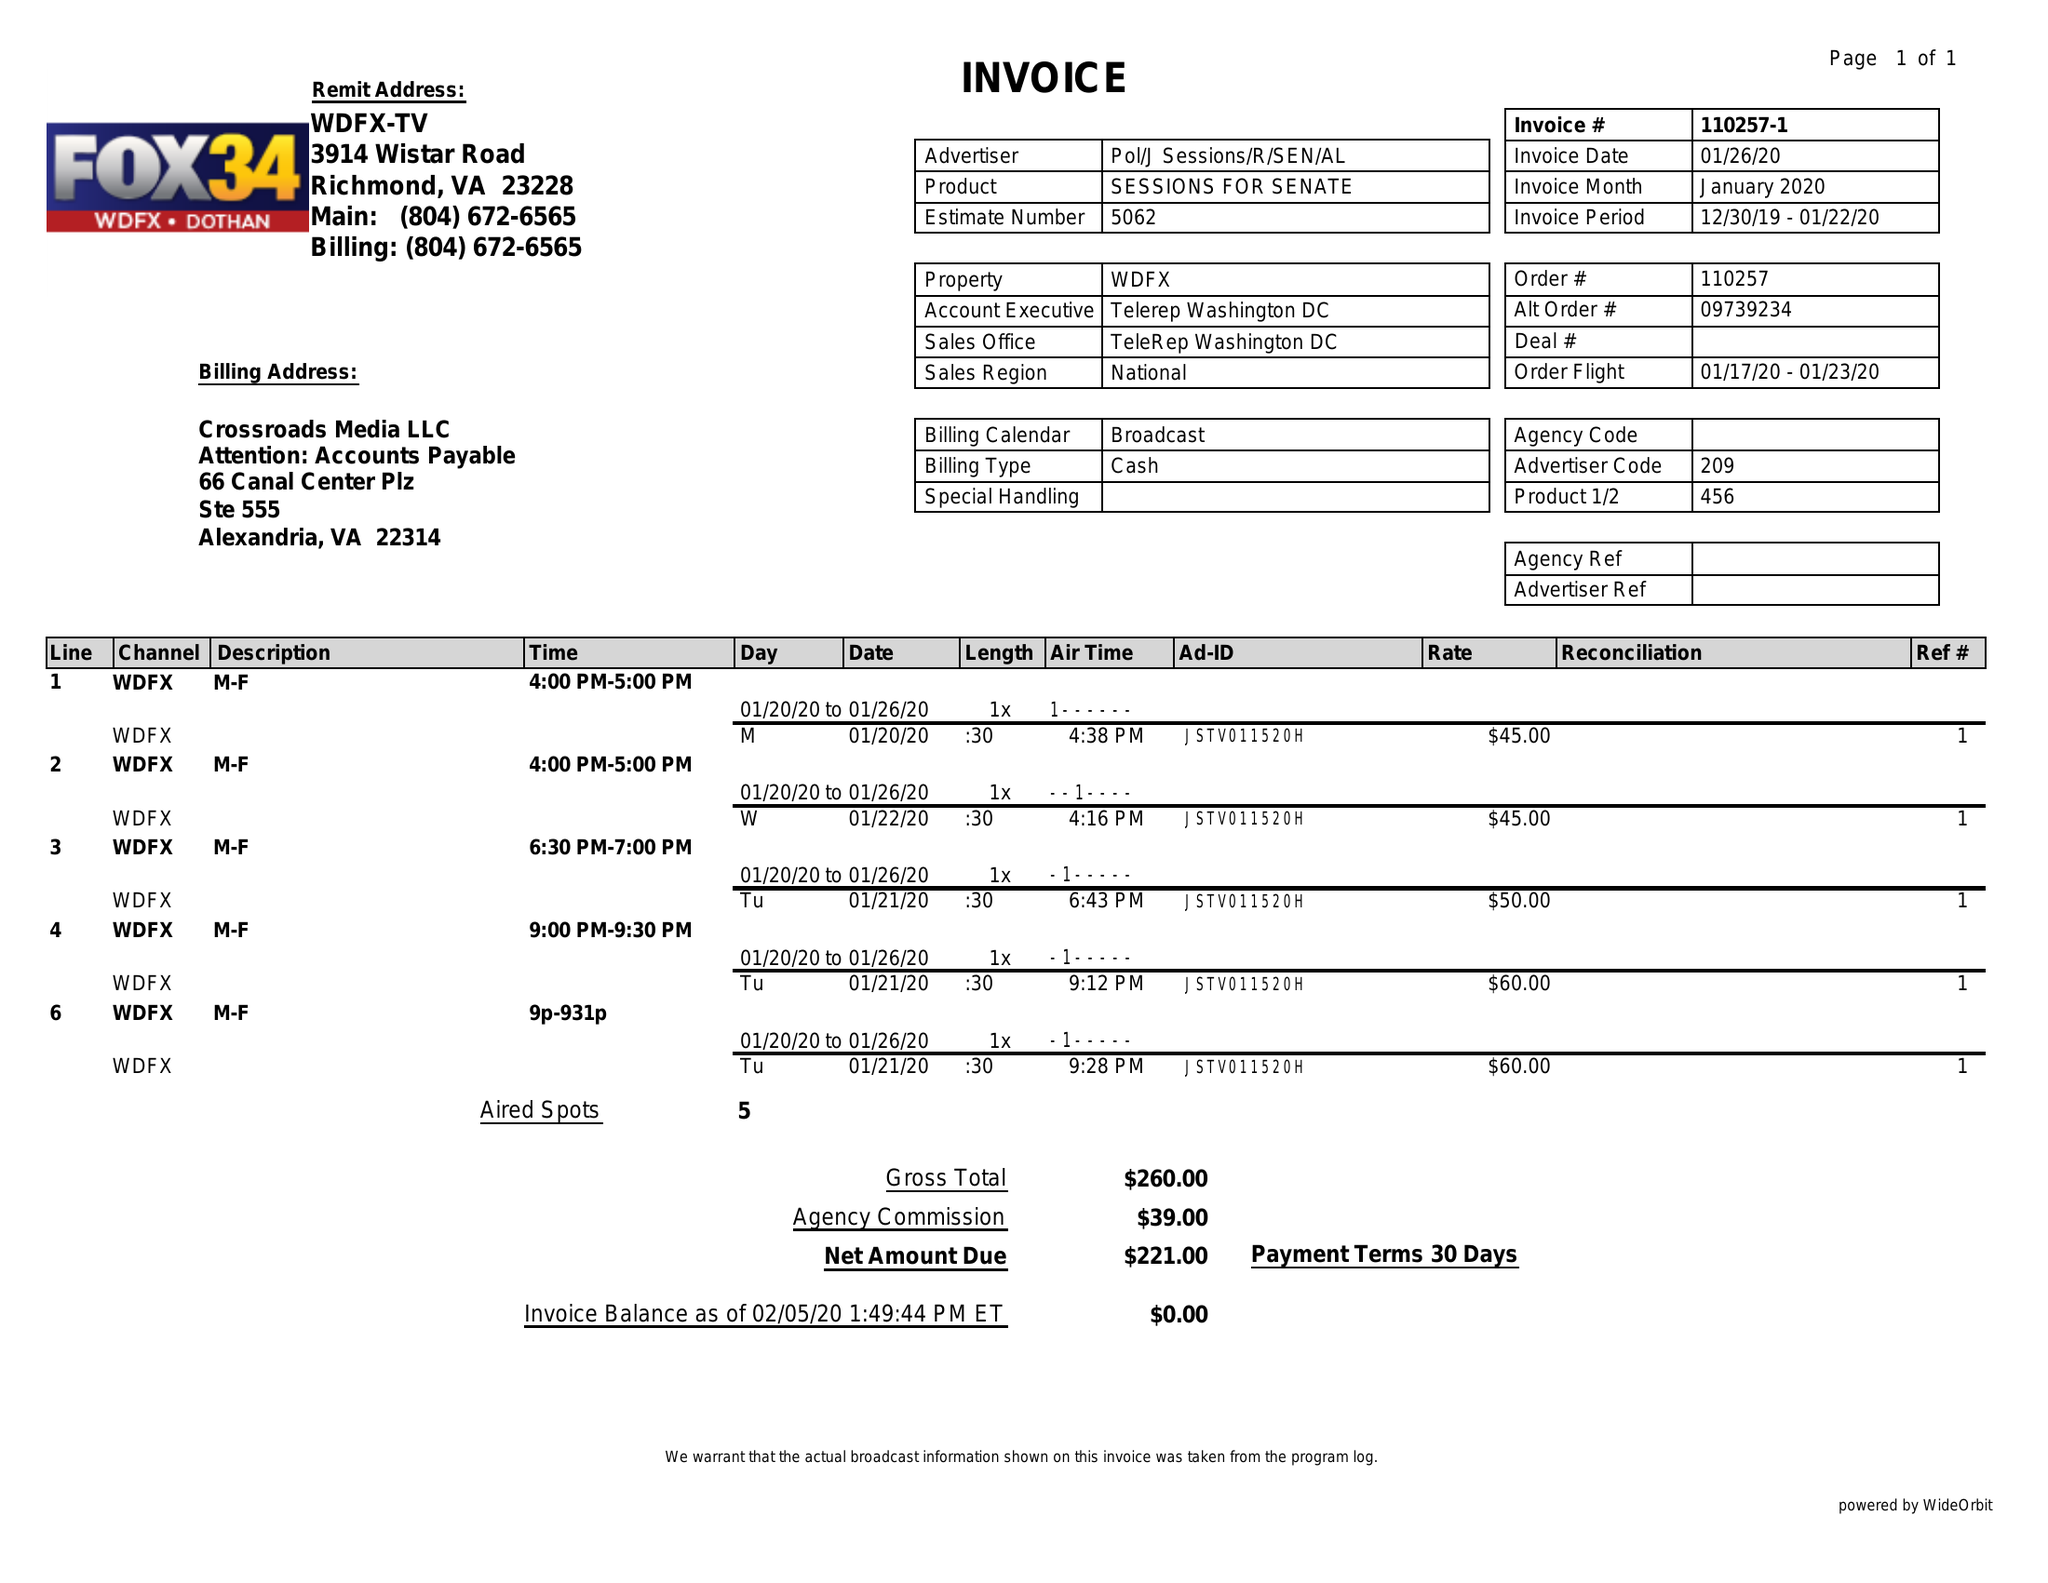What is the value for the advertiser?
Answer the question using a single word or phrase. POL/JSESSIONS/R/SEN/AL 